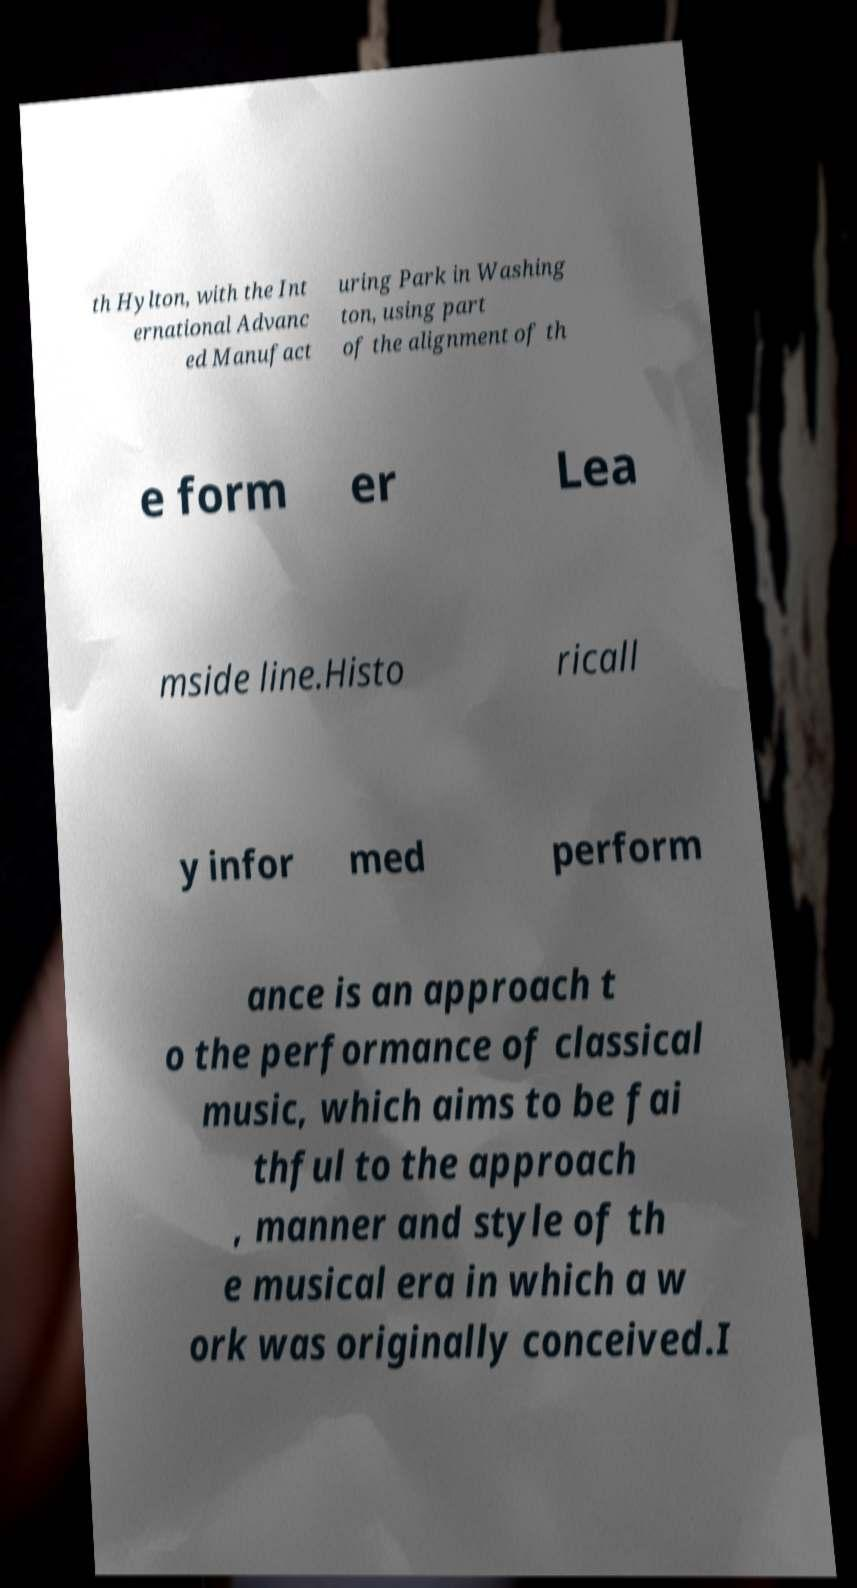Can you accurately transcribe the text from the provided image for me? th Hylton, with the Int ernational Advanc ed Manufact uring Park in Washing ton, using part of the alignment of th e form er Lea mside line.Histo ricall y infor med perform ance is an approach t o the performance of classical music, which aims to be fai thful to the approach , manner and style of th e musical era in which a w ork was originally conceived.I 